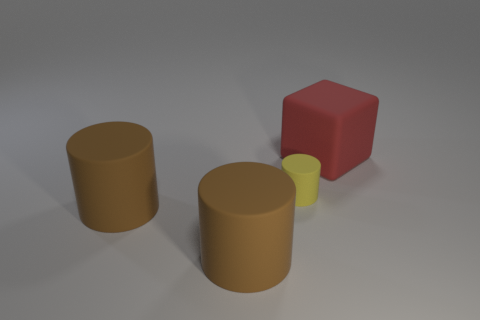How many other things are the same shape as the large red matte thing?
Your answer should be compact. 0. Are there any other things that are the same color as the matte cube?
Your answer should be very brief. No. Does the tiny object have the same color as the big thing that is behind the tiny yellow thing?
Make the answer very short. No. What number of other objects are there of the same size as the rubber cube?
Provide a succinct answer. 2. How many balls are either large things or large blue rubber things?
Give a very brief answer. 0. Does the large object to the right of the small rubber cylinder have the same shape as the small object?
Provide a short and direct response. No. Is the number of matte cylinders that are right of the block greater than the number of big things?
Offer a very short reply. No. What number of things are either large things that are left of the big red rubber object or rubber cylinders?
Offer a terse response. 3. Are there any tiny yellow things made of the same material as the yellow cylinder?
Your answer should be very brief. No. Are there any matte objects left of the large object that is behind the yellow thing?
Your answer should be very brief. Yes. 